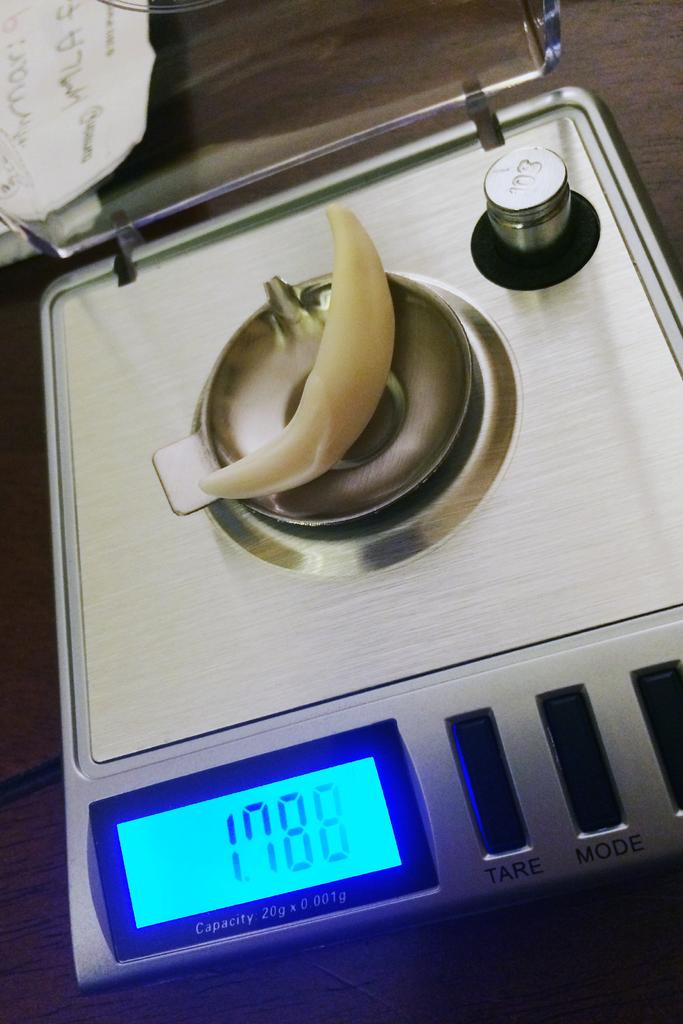What is placed on the digital weight machine in the image? There is an object on the digital weight machine in the image. What information is displayed on the digital weight machine's screen? The digital weight machine's screen displays some numbers. What type of test is being conducted in the image? There is no test being conducted in the image; it only shows an object on a digital weight machine and the displayed numbers. What role does the war play in the image? There is no reference to a war in the image; it only shows an object on a digital weight machine and the displayed numbers. 